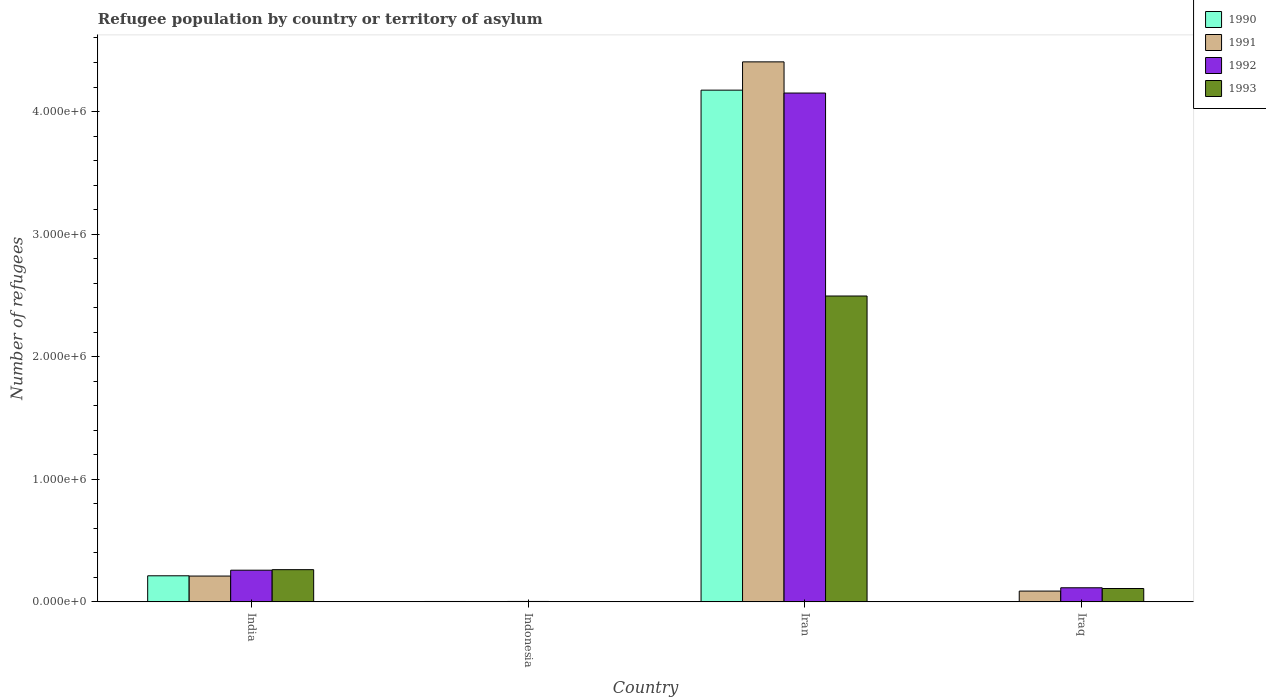How many different coloured bars are there?
Keep it short and to the point. 4. Are the number of bars per tick equal to the number of legend labels?
Keep it short and to the point. Yes. Are the number of bars on each tick of the X-axis equal?
Offer a terse response. Yes. What is the label of the 2nd group of bars from the left?
Ensure brevity in your answer.  Indonesia. What is the number of refugees in 1993 in Indonesia?
Make the answer very short. 2402. Across all countries, what is the maximum number of refugees in 1992?
Offer a terse response. 4.15e+06. Across all countries, what is the minimum number of refugees in 1992?
Make the answer very short. 3530. In which country was the number of refugees in 1993 maximum?
Make the answer very short. Iran. What is the total number of refugees in 1990 in the graph?
Your answer should be very brief. 4.39e+06. What is the difference between the number of refugees in 1992 in India and that in Iran?
Your answer should be compact. -3.89e+06. What is the difference between the number of refugees in 1993 in Iran and the number of refugees in 1992 in Indonesia?
Give a very brief answer. 2.49e+06. What is the average number of refugees in 1991 per country?
Make the answer very short. 1.18e+06. What is the difference between the number of refugees of/in 1990 and number of refugees of/in 1993 in Iraq?
Offer a terse response. -1.08e+05. In how many countries, is the number of refugees in 1991 greater than 4200000?
Provide a short and direct response. 1. What is the ratio of the number of refugees in 1991 in Indonesia to that in Iran?
Provide a short and direct response. 0. Is the number of refugees in 1990 in India less than that in Iran?
Offer a terse response. Yes. What is the difference between the highest and the second highest number of refugees in 1990?
Offer a very short reply. 4.17e+06. What is the difference between the highest and the lowest number of refugees in 1992?
Your response must be concise. 4.15e+06. Is the sum of the number of refugees in 1990 in India and Iraq greater than the maximum number of refugees in 1993 across all countries?
Ensure brevity in your answer.  No. Is it the case that in every country, the sum of the number of refugees in 1990 and number of refugees in 1992 is greater than the sum of number of refugees in 1993 and number of refugees in 1991?
Provide a short and direct response. No. What does the 2nd bar from the left in India represents?
Your response must be concise. 1991. How many bars are there?
Keep it short and to the point. 16. Are all the bars in the graph horizontal?
Offer a terse response. No. How many countries are there in the graph?
Keep it short and to the point. 4. Are the values on the major ticks of Y-axis written in scientific E-notation?
Ensure brevity in your answer.  Yes. Does the graph contain any zero values?
Offer a terse response. No. Does the graph contain grids?
Provide a short and direct response. No. Where does the legend appear in the graph?
Your answer should be compact. Top right. How many legend labels are there?
Offer a very short reply. 4. How are the legend labels stacked?
Your response must be concise. Vertical. What is the title of the graph?
Provide a short and direct response. Refugee population by country or territory of asylum. What is the label or title of the Y-axis?
Offer a very short reply. Number of refugees. What is the Number of refugees in 1990 in India?
Your answer should be very brief. 2.13e+05. What is the Number of refugees in 1991 in India?
Your response must be concise. 2.11e+05. What is the Number of refugees of 1992 in India?
Make the answer very short. 2.58e+05. What is the Number of refugees in 1993 in India?
Offer a very short reply. 2.63e+05. What is the Number of refugees in 1990 in Indonesia?
Ensure brevity in your answer.  3278. What is the Number of refugees in 1991 in Indonesia?
Your answer should be very brief. 3156. What is the Number of refugees of 1992 in Indonesia?
Offer a terse response. 3530. What is the Number of refugees of 1993 in Indonesia?
Keep it short and to the point. 2402. What is the Number of refugees in 1990 in Iran?
Provide a short and direct response. 4.17e+06. What is the Number of refugees of 1991 in Iran?
Give a very brief answer. 4.40e+06. What is the Number of refugees in 1992 in Iran?
Provide a succinct answer. 4.15e+06. What is the Number of refugees in 1993 in Iran?
Offer a terse response. 2.50e+06. What is the Number of refugees in 1990 in Iraq?
Your answer should be compact. 900. What is the Number of refugees of 1991 in Iraq?
Make the answer very short. 8.80e+04. What is the Number of refugees of 1992 in Iraq?
Offer a very short reply. 1.15e+05. What is the Number of refugees in 1993 in Iraq?
Your response must be concise. 1.09e+05. Across all countries, what is the maximum Number of refugees of 1990?
Provide a short and direct response. 4.17e+06. Across all countries, what is the maximum Number of refugees of 1991?
Give a very brief answer. 4.40e+06. Across all countries, what is the maximum Number of refugees in 1992?
Keep it short and to the point. 4.15e+06. Across all countries, what is the maximum Number of refugees in 1993?
Your answer should be very brief. 2.50e+06. Across all countries, what is the minimum Number of refugees in 1990?
Make the answer very short. 900. Across all countries, what is the minimum Number of refugees of 1991?
Offer a very short reply. 3156. Across all countries, what is the minimum Number of refugees in 1992?
Offer a very short reply. 3530. Across all countries, what is the minimum Number of refugees of 1993?
Give a very brief answer. 2402. What is the total Number of refugees of 1990 in the graph?
Give a very brief answer. 4.39e+06. What is the total Number of refugees of 1991 in the graph?
Give a very brief answer. 4.71e+06. What is the total Number of refugees in 1992 in the graph?
Keep it short and to the point. 4.53e+06. What is the total Number of refugees of 1993 in the graph?
Give a very brief answer. 2.87e+06. What is the difference between the Number of refugees of 1990 in India and that in Indonesia?
Provide a short and direct response. 2.09e+05. What is the difference between the Number of refugees of 1991 in India and that in Indonesia?
Your answer should be very brief. 2.07e+05. What is the difference between the Number of refugees of 1992 in India and that in Indonesia?
Provide a short and direct response. 2.55e+05. What is the difference between the Number of refugees in 1993 in India and that in Indonesia?
Ensure brevity in your answer.  2.60e+05. What is the difference between the Number of refugees of 1990 in India and that in Iran?
Your response must be concise. -3.96e+06. What is the difference between the Number of refugees of 1991 in India and that in Iran?
Offer a very short reply. -4.19e+06. What is the difference between the Number of refugees in 1992 in India and that in Iran?
Offer a terse response. -3.89e+06. What is the difference between the Number of refugees in 1993 in India and that in Iran?
Your answer should be very brief. -2.23e+06. What is the difference between the Number of refugees in 1990 in India and that in Iraq?
Give a very brief answer. 2.12e+05. What is the difference between the Number of refugees in 1991 in India and that in Iraq?
Your response must be concise. 1.23e+05. What is the difference between the Number of refugees of 1992 in India and that in Iraq?
Provide a succinct answer. 1.43e+05. What is the difference between the Number of refugees of 1993 in India and that in Iraq?
Offer a very short reply. 1.54e+05. What is the difference between the Number of refugees of 1990 in Indonesia and that in Iran?
Give a very brief answer. -4.17e+06. What is the difference between the Number of refugees in 1991 in Indonesia and that in Iran?
Your response must be concise. -4.40e+06. What is the difference between the Number of refugees in 1992 in Indonesia and that in Iran?
Make the answer very short. -4.15e+06. What is the difference between the Number of refugees of 1993 in Indonesia and that in Iran?
Offer a very short reply. -2.49e+06. What is the difference between the Number of refugees in 1990 in Indonesia and that in Iraq?
Your answer should be very brief. 2378. What is the difference between the Number of refugees in 1991 in Indonesia and that in Iraq?
Make the answer very short. -8.48e+04. What is the difference between the Number of refugees of 1992 in Indonesia and that in Iraq?
Your answer should be very brief. -1.11e+05. What is the difference between the Number of refugees in 1993 in Indonesia and that in Iraq?
Keep it short and to the point. -1.07e+05. What is the difference between the Number of refugees in 1990 in Iran and that in Iraq?
Ensure brevity in your answer.  4.17e+06. What is the difference between the Number of refugees of 1991 in Iran and that in Iraq?
Offer a very short reply. 4.32e+06. What is the difference between the Number of refugees in 1992 in Iran and that in Iraq?
Provide a succinct answer. 4.04e+06. What is the difference between the Number of refugees of 1993 in Iran and that in Iraq?
Offer a terse response. 2.39e+06. What is the difference between the Number of refugees of 1990 in India and the Number of refugees of 1991 in Indonesia?
Offer a terse response. 2.10e+05. What is the difference between the Number of refugees of 1990 in India and the Number of refugees of 1992 in Indonesia?
Your response must be concise. 2.09e+05. What is the difference between the Number of refugees of 1990 in India and the Number of refugees of 1993 in Indonesia?
Offer a terse response. 2.10e+05. What is the difference between the Number of refugees in 1991 in India and the Number of refugees in 1992 in Indonesia?
Your answer should be very brief. 2.07e+05. What is the difference between the Number of refugees of 1991 in India and the Number of refugees of 1993 in Indonesia?
Give a very brief answer. 2.08e+05. What is the difference between the Number of refugees in 1992 in India and the Number of refugees in 1993 in Indonesia?
Offer a very short reply. 2.56e+05. What is the difference between the Number of refugees in 1990 in India and the Number of refugees in 1991 in Iran?
Offer a very short reply. -4.19e+06. What is the difference between the Number of refugees of 1990 in India and the Number of refugees of 1992 in Iran?
Your response must be concise. -3.94e+06. What is the difference between the Number of refugees of 1990 in India and the Number of refugees of 1993 in Iran?
Offer a terse response. -2.28e+06. What is the difference between the Number of refugees in 1991 in India and the Number of refugees in 1992 in Iran?
Provide a succinct answer. -3.94e+06. What is the difference between the Number of refugees in 1991 in India and the Number of refugees in 1993 in Iran?
Your answer should be compact. -2.28e+06. What is the difference between the Number of refugees of 1992 in India and the Number of refugees of 1993 in Iran?
Keep it short and to the point. -2.24e+06. What is the difference between the Number of refugees of 1990 in India and the Number of refugees of 1991 in Iraq?
Provide a succinct answer. 1.25e+05. What is the difference between the Number of refugees in 1990 in India and the Number of refugees in 1992 in Iraq?
Offer a very short reply. 9.77e+04. What is the difference between the Number of refugees of 1990 in India and the Number of refugees of 1993 in Iraq?
Give a very brief answer. 1.04e+05. What is the difference between the Number of refugees of 1991 in India and the Number of refugees of 1992 in Iraq?
Your answer should be very brief. 9.56e+04. What is the difference between the Number of refugees in 1991 in India and the Number of refugees in 1993 in Iraq?
Your answer should be very brief. 1.02e+05. What is the difference between the Number of refugees in 1992 in India and the Number of refugees in 1993 in Iraq?
Make the answer very short. 1.49e+05. What is the difference between the Number of refugees in 1990 in Indonesia and the Number of refugees in 1991 in Iran?
Keep it short and to the point. -4.40e+06. What is the difference between the Number of refugees in 1990 in Indonesia and the Number of refugees in 1992 in Iran?
Your answer should be compact. -4.15e+06. What is the difference between the Number of refugees of 1990 in Indonesia and the Number of refugees of 1993 in Iran?
Your answer should be very brief. -2.49e+06. What is the difference between the Number of refugees in 1991 in Indonesia and the Number of refugees in 1992 in Iran?
Offer a terse response. -4.15e+06. What is the difference between the Number of refugees of 1991 in Indonesia and the Number of refugees of 1993 in Iran?
Keep it short and to the point. -2.49e+06. What is the difference between the Number of refugees in 1992 in Indonesia and the Number of refugees in 1993 in Iran?
Provide a short and direct response. -2.49e+06. What is the difference between the Number of refugees in 1990 in Indonesia and the Number of refugees in 1991 in Iraq?
Your answer should be very brief. -8.47e+04. What is the difference between the Number of refugees of 1990 in Indonesia and the Number of refugees of 1992 in Iraq?
Offer a terse response. -1.12e+05. What is the difference between the Number of refugees in 1990 in Indonesia and the Number of refugees in 1993 in Iraq?
Your response must be concise. -1.06e+05. What is the difference between the Number of refugees in 1991 in Indonesia and the Number of refugees in 1992 in Iraq?
Keep it short and to the point. -1.12e+05. What is the difference between the Number of refugees of 1991 in Indonesia and the Number of refugees of 1993 in Iraq?
Ensure brevity in your answer.  -1.06e+05. What is the difference between the Number of refugees in 1992 in Indonesia and the Number of refugees in 1993 in Iraq?
Provide a short and direct response. -1.06e+05. What is the difference between the Number of refugees of 1990 in Iran and the Number of refugees of 1991 in Iraq?
Keep it short and to the point. 4.09e+06. What is the difference between the Number of refugees of 1990 in Iran and the Number of refugees of 1992 in Iraq?
Ensure brevity in your answer.  4.06e+06. What is the difference between the Number of refugees of 1990 in Iran and the Number of refugees of 1993 in Iraq?
Provide a short and direct response. 4.07e+06. What is the difference between the Number of refugees in 1991 in Iran and the Number of refugees in 1992 in Iraq?
Offer a very short reply. 4.29e+06. What is the difference between the Number of refugees in 1991 in Iran and the Number of refugees in 1993 in Iraq?
Offer a terse response. 4.30e+06. What is the difference between the Number of refugees of 1992 in Iran and the Number of refugees of 1993 in Iraq?
Offer a very short reply. 4.04e+06. What is the average Number of refugees in 1990 per country?
Make the answer very short. 1.10e+06. What is the average Number of refugees in 1991 per country?
Ensure brevity in your answer.  1.18e+06. What is the average Number of refugees of 1992 per country?
Your answer should be compact. 1.13e+06. What is the average Number of refugees in 1993 per country?
Your response must be concise. 7.17e+05. What is the difference between the Number of refugees of 1990 and Number of refugees of 1991 in India?
Provide a succinct answer. 2174. What is the difference between the Number of refugees of 1990 and Number of refugees of 1992 in India?
Your answer should be very brief. -4.56e+04. What is the difference between the Number of refugees in 1990 and Number of refugees in 1993 in India?
Keep it short and to the point. -5.01e+04. What is the difference between the Number of refugees of 1991 and Number of refugees of 1992 in India?
Make the answer very short. -4.78e+04. What is the difference between the Number of refugees in 1991 and Number of refugees in 1993 in India?
Provide a short and direct response. -5.22e+04. What is the difference between the Number of refugees of 1992 and Number of refugees of 1993 in India?
Your answer should be very brief. -4426. What is the difference between the Number of refugees of 1990 and Number of refugees of 1991 in Indonesia?
Your answer should be very brief. 122. What is the difference between the Number of refugees in 1990 and Number of refugees in 1992 in Indonesia?
Your answer should be very brief. -252. What is the difference between the Number of refugees of 1990 and Number of refugees of 1993 in Indonesia?
Provide a succinct answer. 876. What is the difference between the Number of refugees of 1991 and Number of refugees of 1992 in Indonesia?
Your response must be concise. -374. What is the difference between the Number of refugees of 1991 and Number of refugees of 1993 in Indonesia?
Your answer should be very brief. 754. What is the difference between the Number of refugees of 1992 and Number of refugees of 1993 in Indonesia?
Offer a terse response. 1128. What is the difference between the Number of refugees in 1990 and Number of refugees in 1991 in Iran?
Your answer should be very brief. -2.31e+05. What is the difference between the Number of refugees in 1990 and Number of refugees in 1992 in Iran?
Your response must be concise. 2.37e+04. What is the difference between the Number of refugees in 1990 and Number of refugees in 1993 in Iran?
Your answer should be compact. 1.68e+06. What is the difference between the Number of refugees of 1991 and Number of refugees of 1992 in Iran?
Provide a succinct answer. 2.54e+05. What is the difference between the Number of refugees of 1991 and Number of refugees of 1993 in Iran?
Keep it short and to the point. 1.91e+06. What is the difference between the Number of refugees of 1992 and Number of refugees of 1993 in Iran?
Offer a terse response. 1.66e+06. What is the difference between the Number of refugees of 1990 and Number of refugees of 1991 in Iraq?
Keep it short and to the point. -8.71e+04. What is the difference between the Number of refugees of 1990 and Number of refugees of 1992 in Iraq?
Ensure brevity in your answer.  -1.14e+05. What is the difference between the Number of refugees in 1990 and Number of refugees in 1993 in Iraq?
Your response must be concise. -1.08e+05. What is the difference between the Number of refugees of 1991 and Number of refugees of 1992 in Iraq?
Keep it short and to the point. -2.70e+04. What is the difference between the Number of refugees in 1991 and Number of refugees in 1993 in Iraq?
Your answer should be compact. -2.11e+04. What is the difference between the Number of refugees of 1992 and Number of refugees of 1993 in Iraq?
Provide a succinct answer. 5934. What is the ratio of the Number of refugees in 1990 in India to that in Indonesia?
Offer a very short reply. 64.9. What is the ratio of the Number of refugees of 1991 in India to that in Indonesia?
Provide a succinct answer. 66.72. What is the ratio of the Number of refugees in 1992 in India to that in Indonesia?
Your response must be concise. 73.19. What is the ratio of the Number of refugees of 1993 in India to that in Indonesia?
Ensure brevity in your answer.  109.41. What is the ratio of the Number of refugees of 1990 in India to that in Iran?
Offer a terse response. 0.05. What is the ratio of the Number of refugees in 1991 in India to that in Iran?
Provide a short and direct response. 0.05. What is the ratio of the Number of refugees of 1992 in India to that in Iran?
Your answer should be very brief. 0.06. What is the ratio of the Number of refugees of 1993 in India to that in Iran?
Keep it short and to the point. 0.11. What is the ratio of the Number of refugees in 1990 in India to that in Iraq?
Offer a terse response. 236.38. What is the ratio of the Number of refugees in 1991 in India to that in Iraq?
Your answer should be compact. 2.39. What is the ratio of the Number of refugees in 1992 in India to that in Iraq?
Provide a succinct answer. 2.25. What is the ratio of the Number of refugees in 1993 in India to that in Iraq?
Keep it short and to the point. 2.41. What is the ratio of the Number of refugees in 1990 in Indonesia to that in Iran?
Give a very brief answer. 0. What is the ratio of the Number of refugees in 1991 in Indonesia to that in Iran?
Your answer should be compact. 0. What is the ratio of the Number of refugees in 1992 in Indonesia to that in Iran?
Ensure brevity in your answer.  0. What is the ratio of the Number of refugees in 1993 in Indonesia to that in Iran?
Your answer should be very brief. 0. What is the ratio of the Number of refugees in 1990 in Indonesia to that in Iraq?
Keep it short and to the point. 3.64. What is the ratio of the Number of refugees of 1991 in Indonesia to that in Iraq?
Ensure brevity in your answer.  0.04. What is the ratio of the Number of refugees of 1992 in Indonesia to that in Iraq?
Provide a short and direct response. 0.03. What is the ratio of the Number of refugees of 1993 in Indonesia to that in Iraq?
Make the answer very short. 0.02. What is the ratio of the Number of refugees in 1990 in Iran to that in Iraq?
Offer a terse response. 4638.22. What is the ratio of the Number of refugees in 1991 in Iran to that in Iraq?
Provide a succinct answer. 50.06. What is the ratio of the Number of refugees in 1992 in Iran to that in Iraq?
Keep it short and to the point. 36.09. What is the ratio of the Number of refugees in 1993 in Iran to that in Iraq?
Ensure brevity in your answer.  22.88. What is the difference between the highest and the second highest Number of refugees in 1990?
Provide a succinct answer. 3.96e+06. What is the difference between the highest and the second highest Number of refugees of 1991?
Keep it short and to the point. 4.19e+06. What is the difference between the highest and the second highest Number of refugees of 1992?
Make the answer very short. 3.89e+06. What is the difference between the highest and the second highest Number of refugees of 1993?
Offer a very short reply. 2.23e+06. What is the difference between the highest and the lowest Number of refugees of 1990?
Ensure brevity in your answer.  4.17e+06. What is the difference between the highest and the lowest Number of refugees in 1991?
Provide a short and direct response. 4.40e+06. What is the difference between the highest and the lowest Number of refugees of 1992?
Your answer should be compact. 4.15e+06. What is the difference between the highest and the lowest Number of refugees of 1993?
Provide a short and direct response. 2.49e+06. 